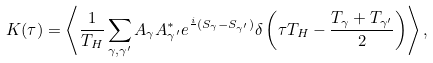<formula> <loc_0><loc_0><loc_500><loc_500>K ( \tau ) = \left \langle \frac { 1 } { T _ { H } } \sum _ { \gamma , \gamma ^ { \prime } } A _ { \gamma } A _ { \gamma ^ { \prime } } ^ { * } e ^ { \frac { i } { } ( S _ { \gamma } - S _ { \gamma ^ { \prime } } ) } \delta \left ( \tau T _ { H } - \frac { T _ { \gamma } + T _ { \gamma ^ { \prime } } } { 2 } \right ) \right \rangle ,</formula> 